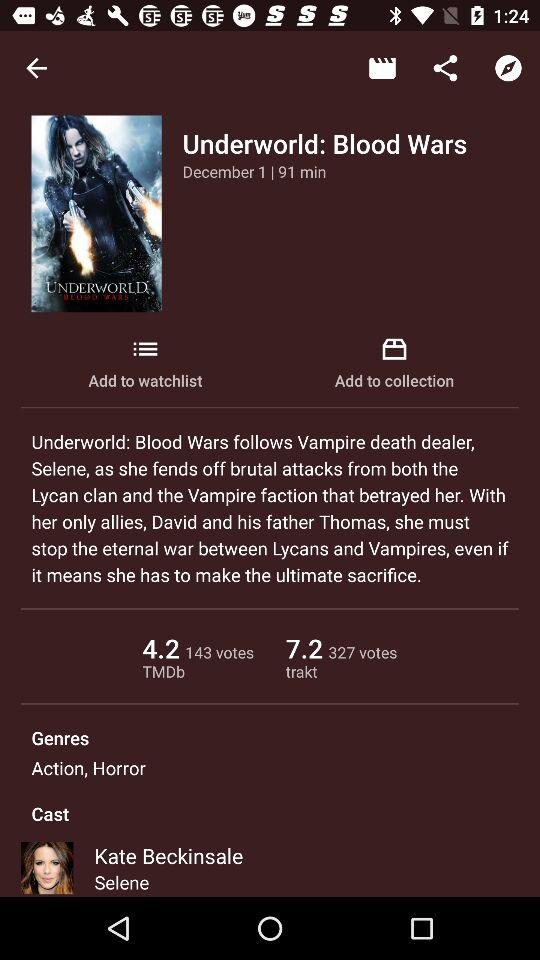What's the movie title? The movie title is "Underworld: Blood Wars". 